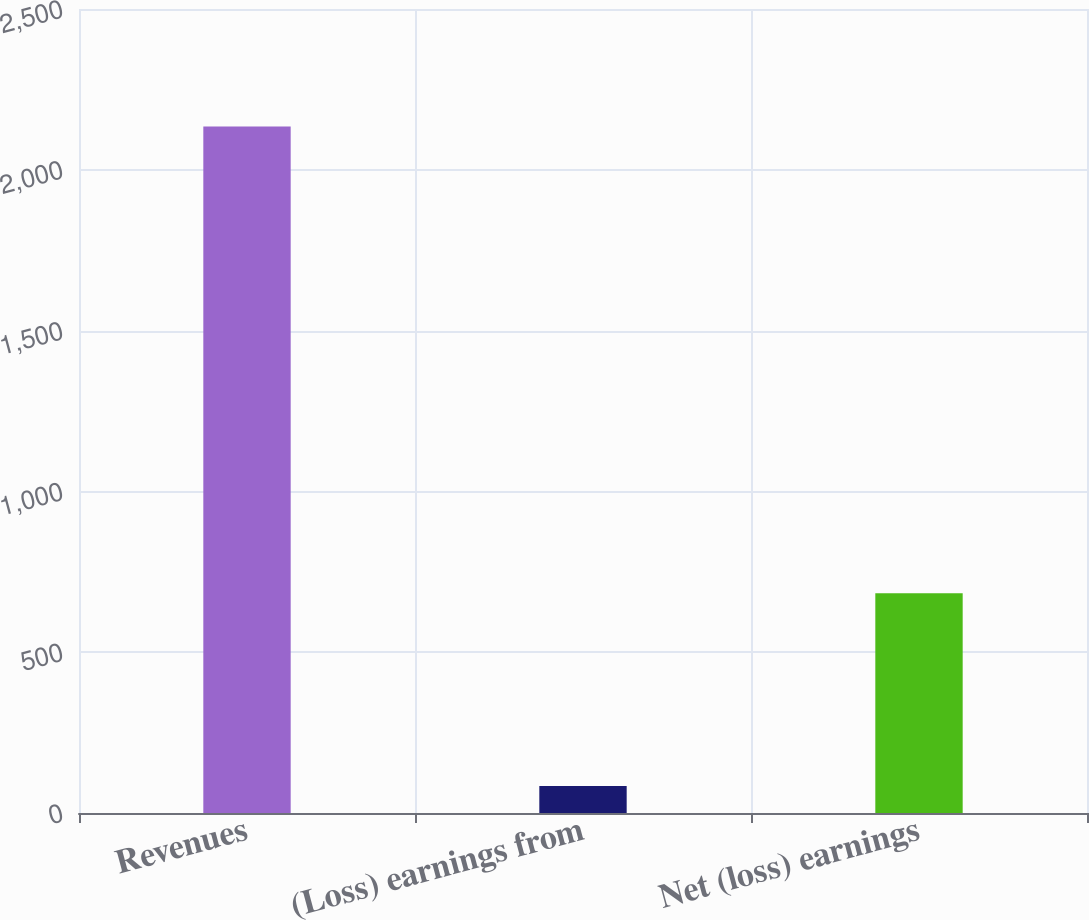<chart> <loc_0><loc_0><loc_500><loc_500><bar_chart><fcel>Revenues<fcel>(Loss) earnings from<fcel>Net (loss) earnings<nl><fcel>2135<fcel>84<fcel>683.1<nl></chart> 